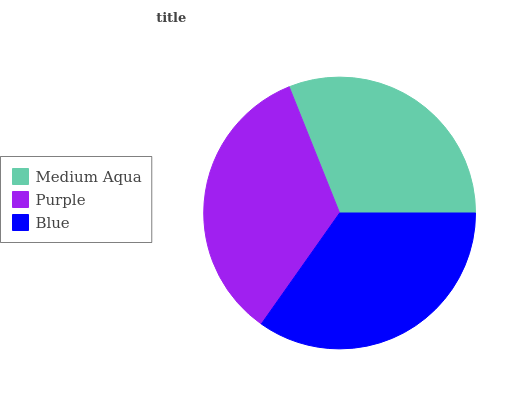Is Medium Aqua the minimum?
Answer yes or no. Yes. Is Blue the maximum?
Answer yes or no. Yes. Is Purple the minimum?
Answer yes or no. No. Is Purple the maximum?
Answer yes or no. No. Is Purple greater than Medium Aqua?
Answer yes or no. Yes. Is Medium Aqua less than Purple?
Answer yes or no. Yes. Is Medium Aqua greater than Purple?
Answer yes or no. No. Is Purple less than Medium Aqua?
Answer yes or no. No. Is Purple the high median?
Answer yes or no. Yes. Is Purple the low median?
Answer yes or no. Yes. Is Medium Aqua the high median?
Answer yes or no. No. Is Medium Aqua the low median?
Answer yes or no. No. 